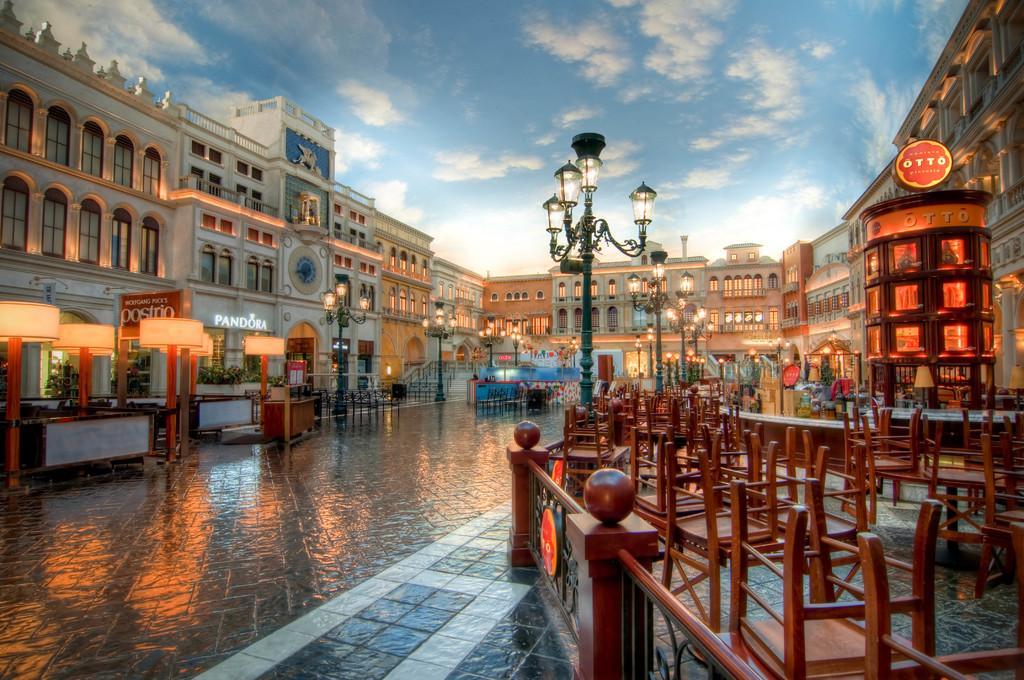In one or two sentences, can you explain what this image depicts? In this image we can see an outside view. In the foreground we can see a group of chairs, tables placed on the ground, barricade and light poles. In the background, we can see a group of buildings with windows, railings, sign boards with text and the cloudy sky. 